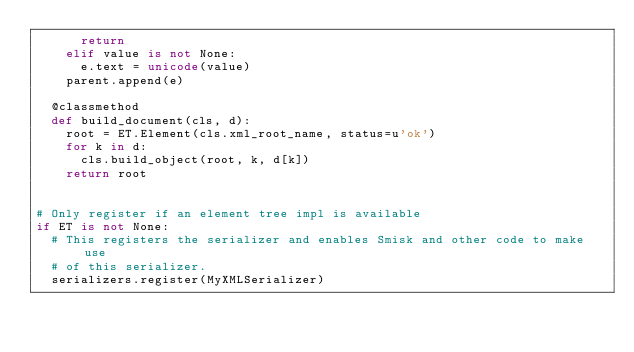Convert code to text. <code><loc_0><loc_0><loc_500><loc_500><_Python_>      return
    elif value is not None:
      e.text = unicode(value)
    parent.append(e)
  
  @classmethod
  def build_document(cls, d):
    root = ET.Element(cls.xml_root_name, status=u'ok')
    for k in d:
      cls.build_object(root, k, d[k])
    return root
  

# Only register if an element tree impl is available
if ET is not None:
  # This registers the serializer and enables Smisk and other code to make use
  # of this serializer.
  serializers.register(MyXMLSerializer)
</code> 